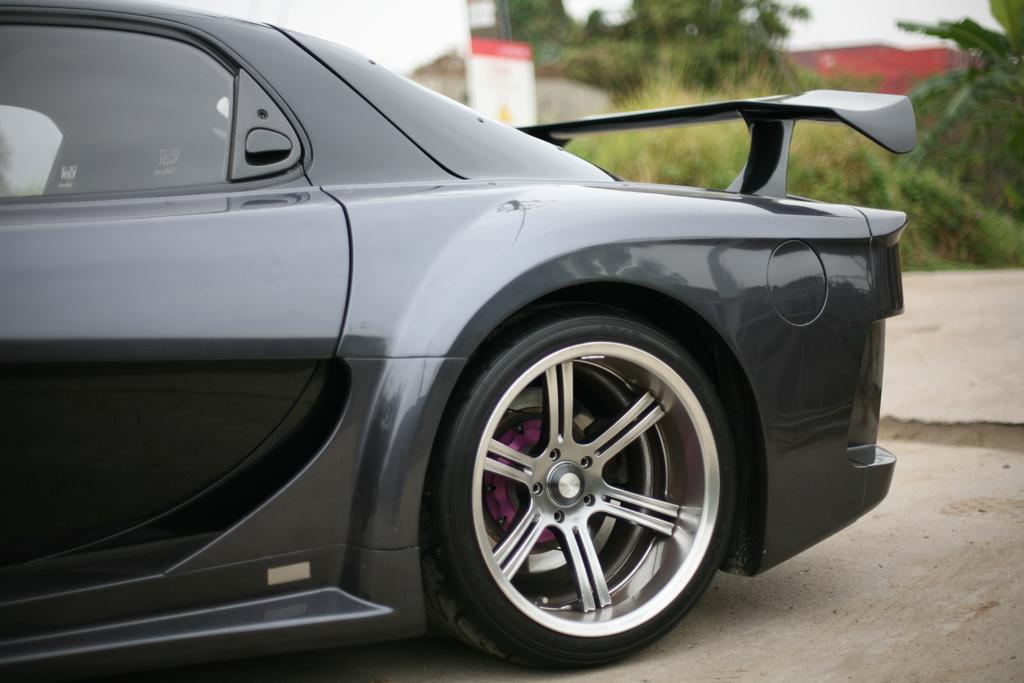Could you give a brief overview of what you see in this image? In this images we can see a car on the ground. In the background the image is blur but we can see a hoarding, building, plants, trees and sky. 